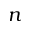<formula> <loc_0><loc_0><loc_500><loc_500>n</formula> 